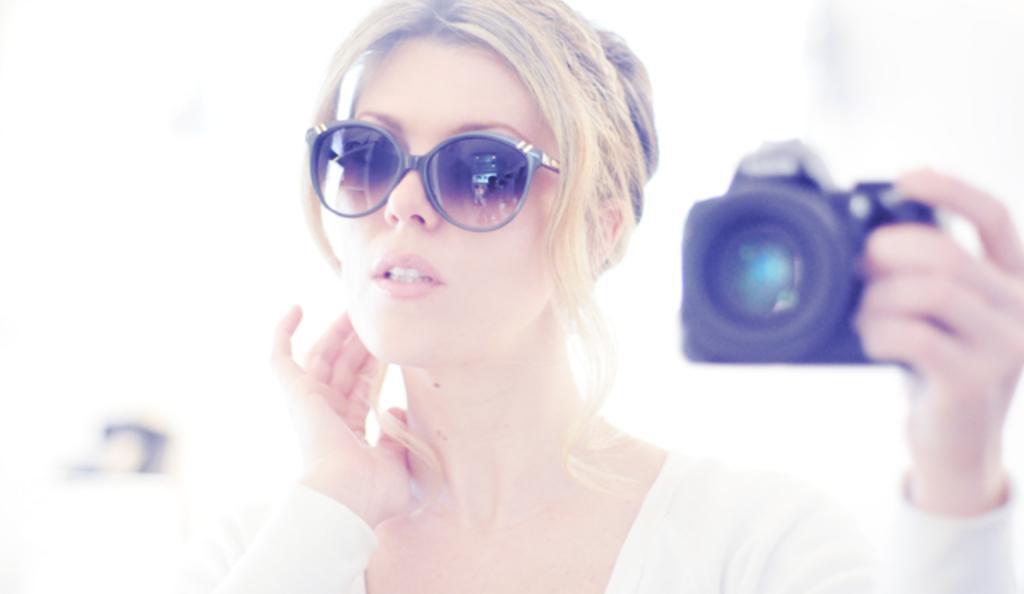Please provide a concise description of this image. This woman wore spectacles and holding a camera. This woman is giving a still. 